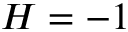<formula> <loc_0><loc_0><loc_500><loc_500>H = - 1</formula> 